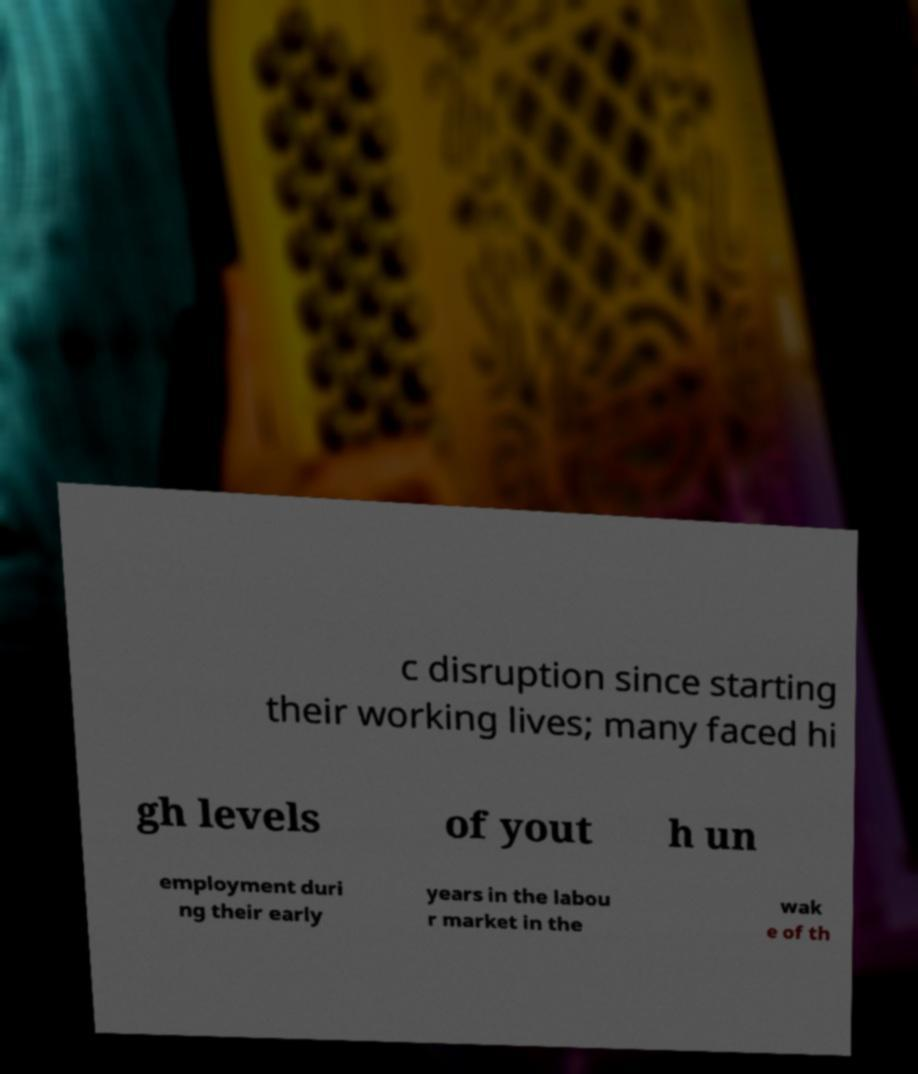I need the written content from this picture converted into text. Can you do that? c disruption since starting their working lives; many faced hi gh levels of yout h un employment duri ng their early years in the labou r market in the wak e of th 